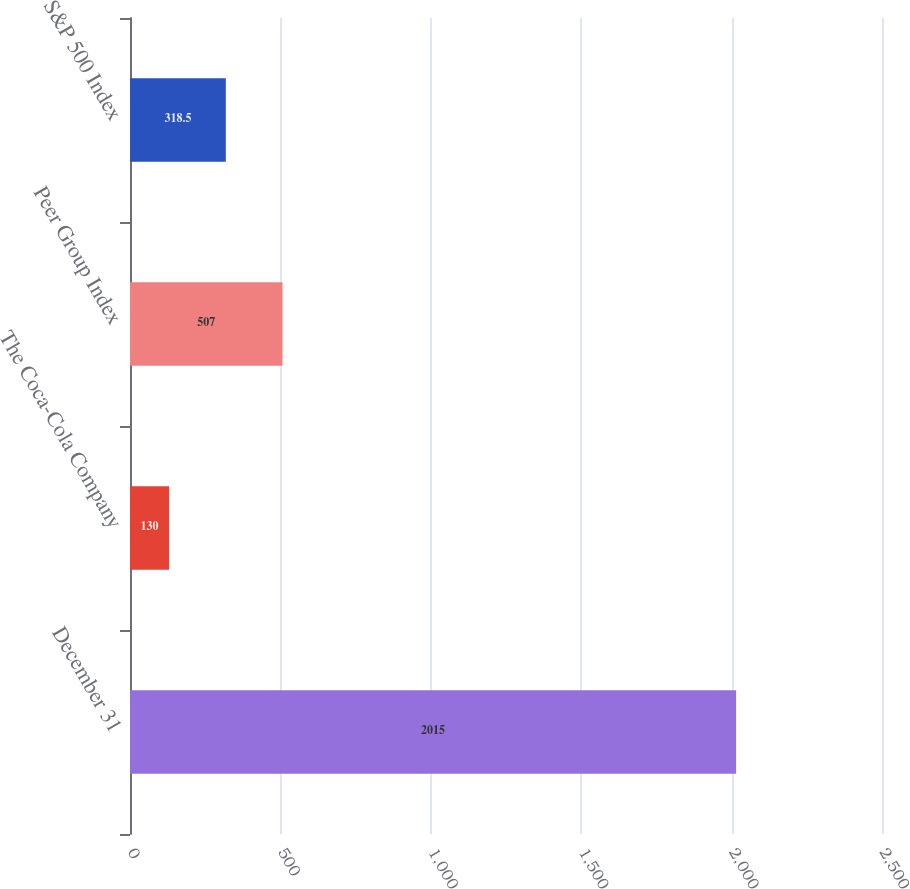<chart> <loc_0><loc_0><loc_500><loc_500><bar_chart><fcel>December 31<fcel>The Coca-Cola Company<fcel>Peer Group Index<fcel>S&P 500 Index<nl><fcel>2015<fcel>130<fcel>507<fcel>318.5<nl></chart> 